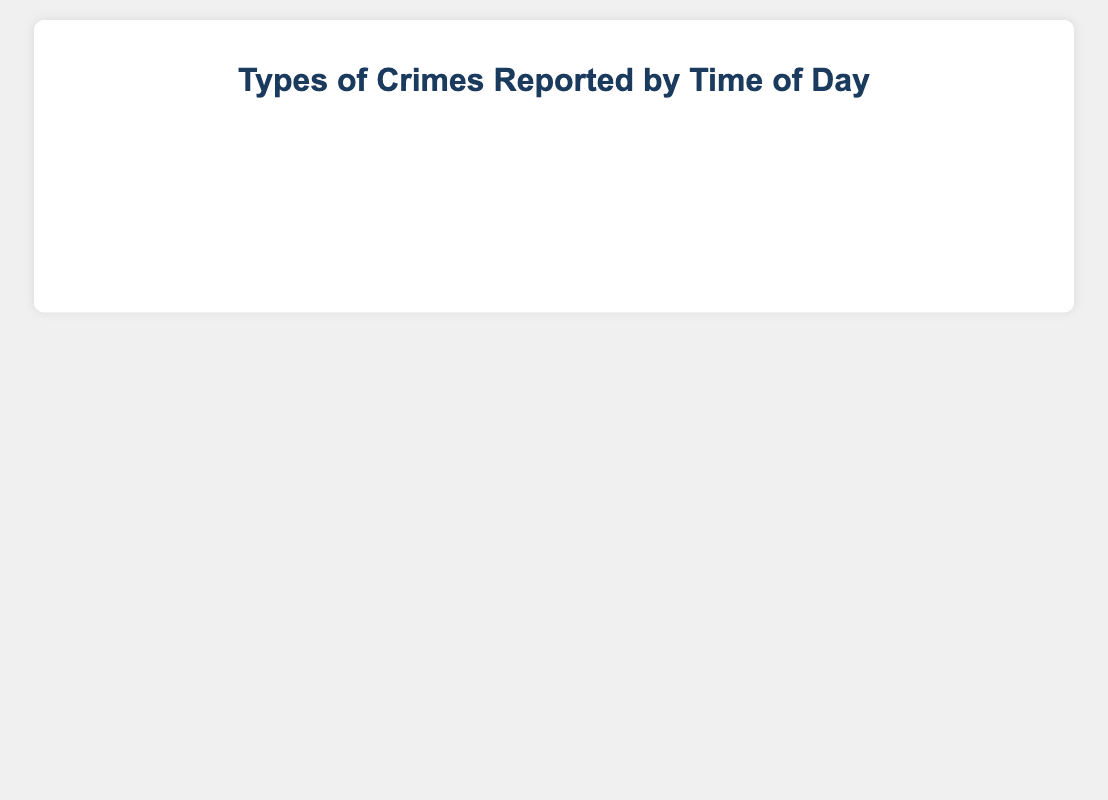What type of crime has the highest number of reports in the 4pm - 8pm period? To find this, look at the bar lengths for all types of crimes corresponding to the 4pm - 8pm period. "Theft" has the highest bar at 220.
Answer: Theft Which time period has the least reports for Assault? Observe the bars corresponding to Assault across all time periods. The shortest bar is for 4am - 8am, which is 20.
Answer: 4am - 8am Compare the total number of reports for Vandalism and Fraud. Which has more reports? Sum the reports for each time period for both Vandalism and Fraud. Vandalism: 40 + 30 + 100 + 120 + 140 + 110 = 540. Fraud: 10 + 15 + 50 + 60 + 65 + 55 = 255. Vandalism has more reports.
Answer: Vandalism What is the average number of Theft reports between noon and midnight? Sum the number of Theft reports from noon-4pm, 4pm-8pm, and 8pm-midnight; then divide by 3. (150 + 220 + 180) / 3 = 550 / 3 = approximately 183.33.
Answer: 183.33 How many more total reports are there for Robbery compared to Burglary? Sum the reports for both Robbery and Burglary. Robbery: 45 + 35 + 90 + 110 + 125 + 130 = 535. Burglary: 25 + 15 + 60 + 75 + 90 + 80 = 345. Difference = 535 - 345 = 190.
Answer: 190 Which crime type has the shortest bar in any time period? Look for the shortest bar across all time periods and crime types. Fraud has the shortest bar in the Midnight - 4am period with 10 reports.
Answer: Fraud What is the total number of reports across all crime types for the 8am - Noon period? Sum the reports for 8am - Noon across all crime types. 200 (Theft) + 50 (Assault) + 60 (Burglary) + 90 (Robbery) + 100 (Vandalism) + 50 (Fraud) = 550.
Answer: 550 During which time period do most Theft incidents occur? Look for the longest bar in the Theft category. The highest is during 4pm - 8pm with 220 reports.
Answer: 4pm - 8pm 